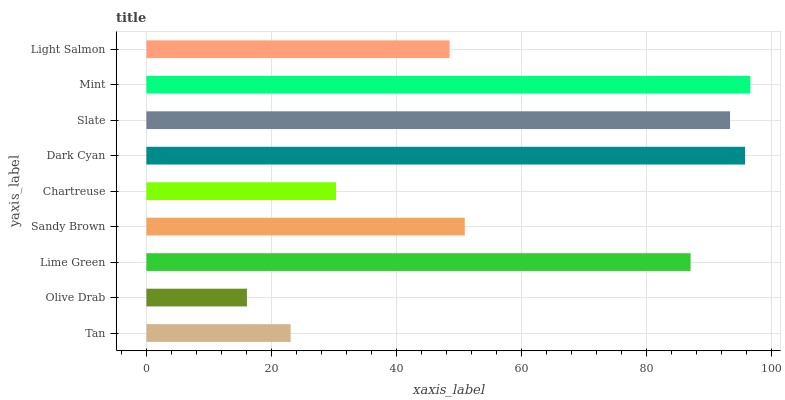Is Olive Drab the minimum?
Answer yes or no. Yes. Is Mint the maximum?
Answer yes or no. Yes. Is Lime Green the minimum?
Answer yes or no. No. Is Lime Green the maximum?
Answer yes or no. No. Is Lime Green greater than Olive Drab?
Answer yes or no. Yes. Is Olive Drab less than Lime Green?
Answer yes or no. Yes. Is Olive Drab greater than Lime Green?
Answer yes or no. No. Is Lime Green less than Olive Drab?
Answer yes or no. No. Is Sandy Brown the high median?
Answer yes or no. Yes. Is Sandy Brown the low median?
Answer yes or no. Yes. Is Slate the high median?
Answer yes or no. No. Is Lime Green the low median?
Answer yes or no. No. 